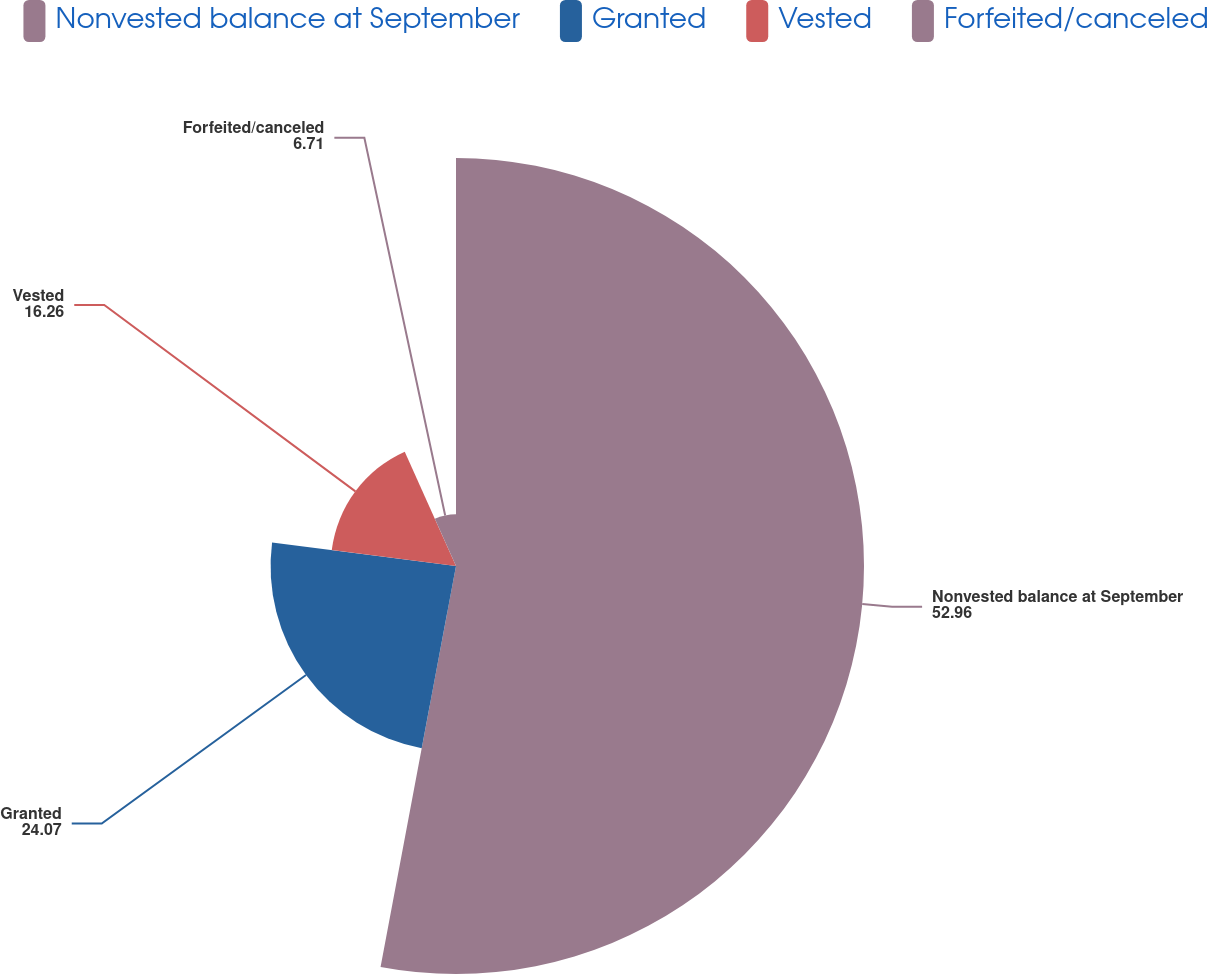<chart> <loc_0><loc_0><loc_500><loc_500><pie_chart><fcel>Nonvested balance at September<fcel>Granted<fcel>Vested<fcel>Forfeited/canceled<nl><fcel>52.96%<fcel>24.07%<fcel>16.26%<fcel>6.71%<nl></chart> 